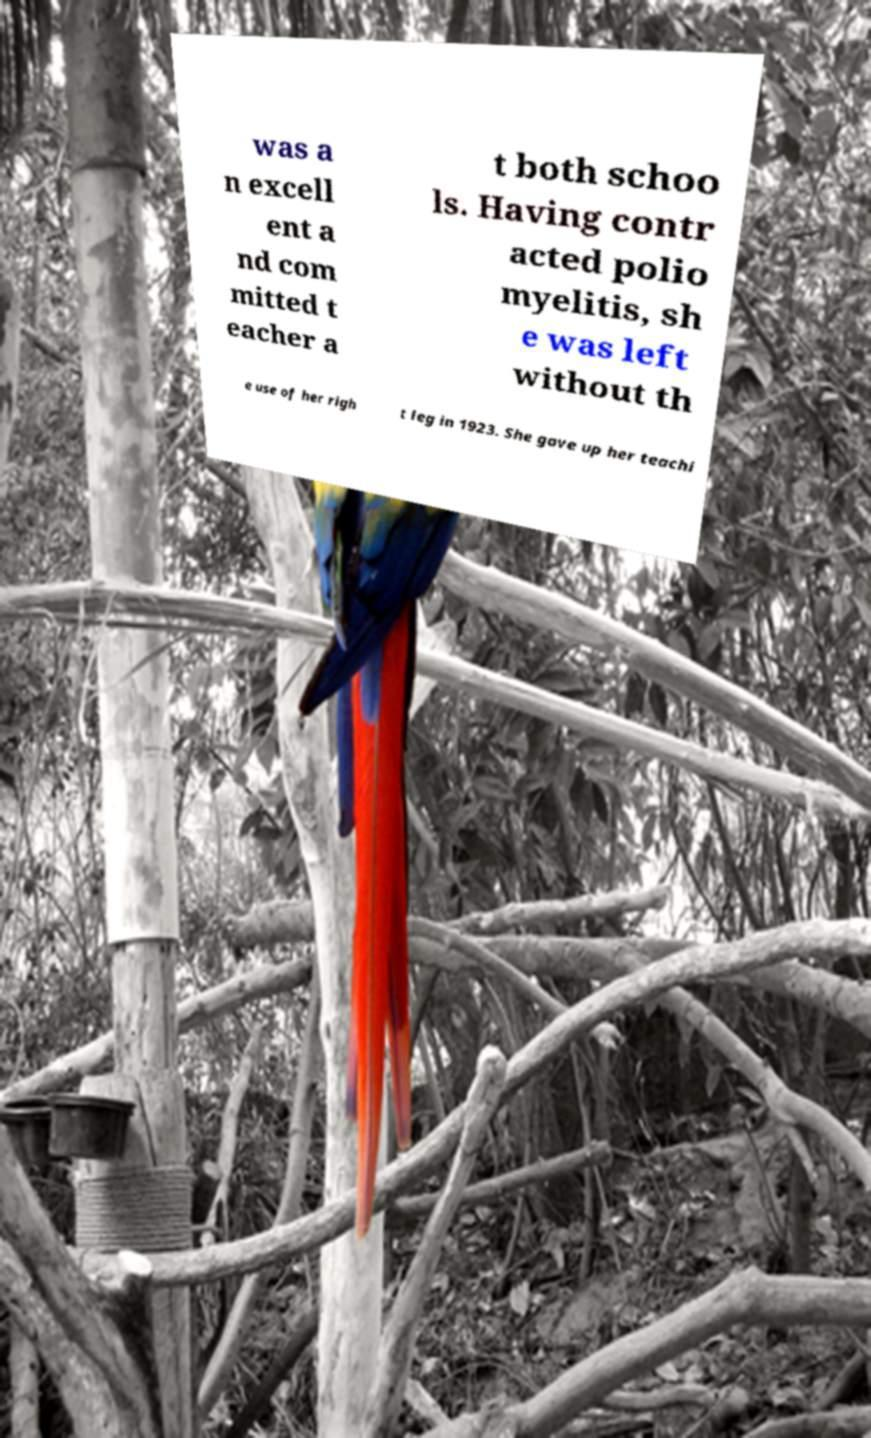Could you extract and type out the text from this image? was a n excell ent a nd com mitted t eacher a t both schoo ls. Having contr acted polio myelitis, sh e was left without th e use of her righ t leg in 1923. She gave up her teachi 